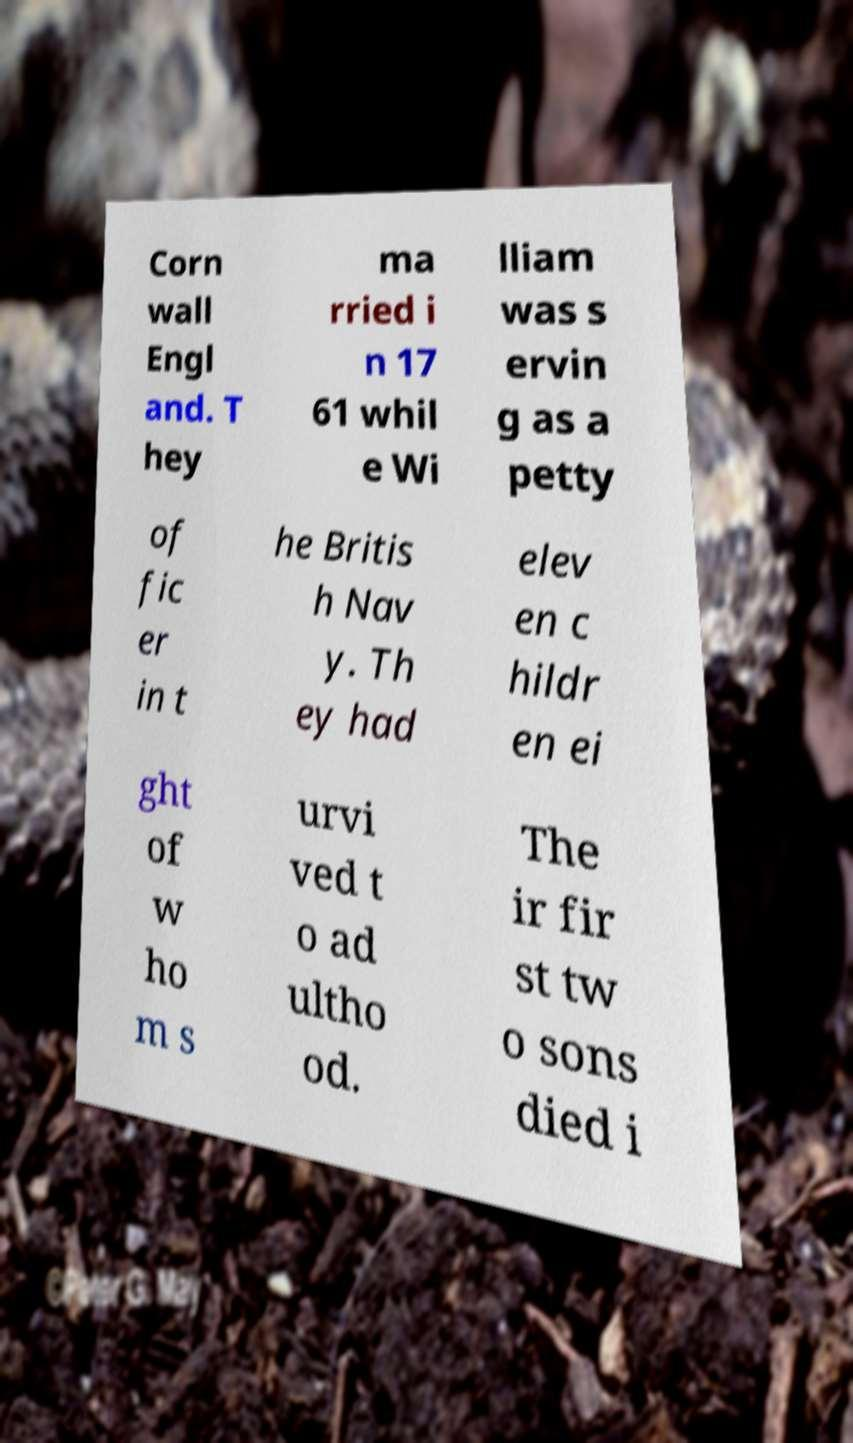Please read and relay the text visible in this image. What does it say? Corn wall Engl and. T hey ma rried i n 17 61 whil e Wi lliam was s ervin g as a petty of fic er in t he Britis h Nav y. Th ey had elev en c hildr en ei ght of w ho m s urvi ved t o ad ultho od. The ir fir st tw o sons died i 